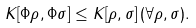Convert formula to latex. <formula><loc_0><loc_0><loc_500><loc_500>K [ \Phi \rho , \Phi \sigma ] \leq K [ \rho , \sigma ] \, ( \forall \rho , \sigma ) .</formula> 